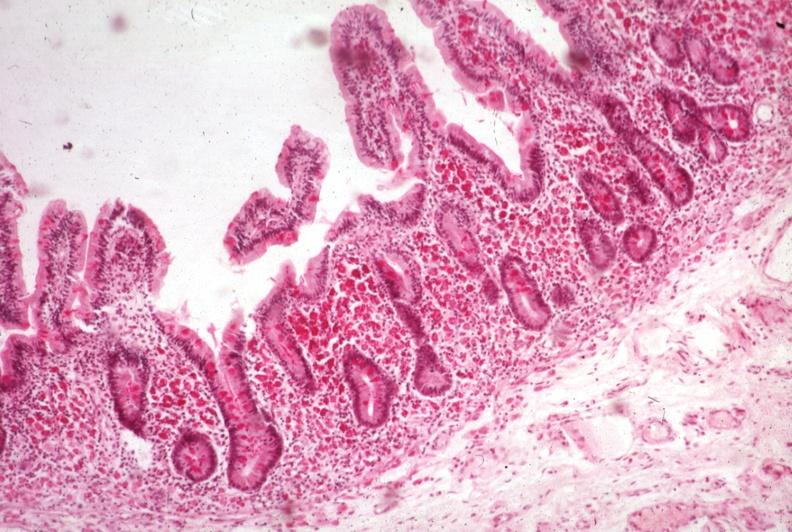s fat necrosis present?
Answer the question using a single word or phrase. No 